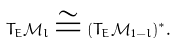<formula> <loc_0><loc_0><loc_500><loc_500>T _ { E } \mathcal { M } _ { l } \cong ( T _ { E } \mathcal { M } _ { 1 - l } ) ^ { * } .</formula> 